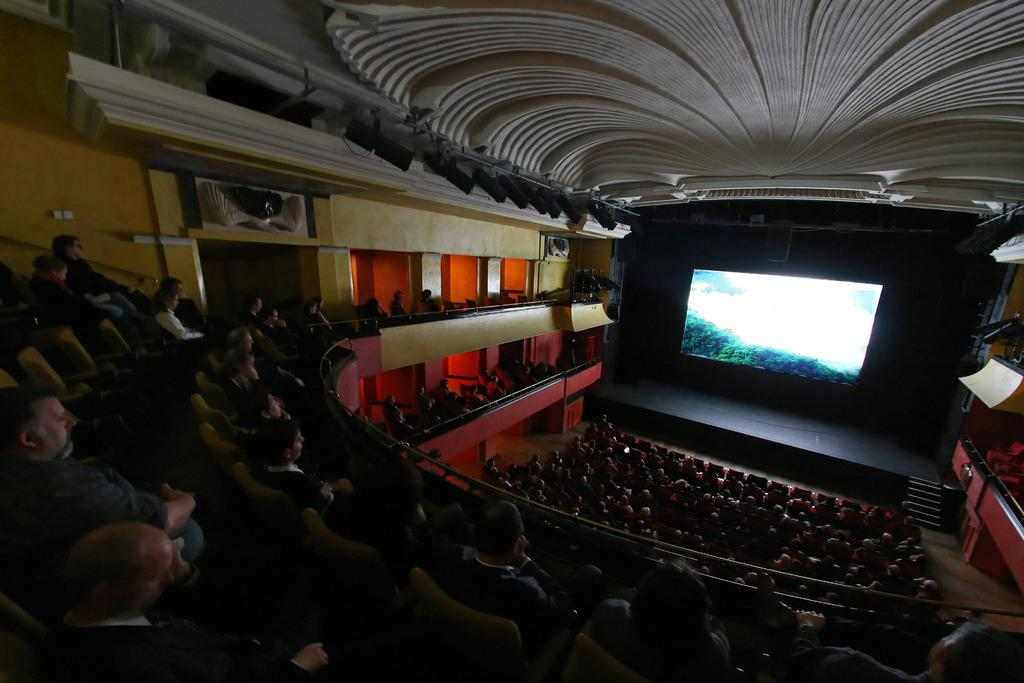What type of venue is depicted in the image? The image appears to be a theater. What are the people in the image doing? There are people seated in chairs in the image. What is the primary feature of the theater? There is a screen visible in the image. How many cherries can be seen hanging from the elbow of the person in the image? There are no cherries or elbows visible in the image; it depicts a theater with people seated in chairs and a screen. 